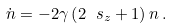Convert formula to latex. <formula><loc_0><loc_0><loc_500><loc_500>\dot { n } = - 2 \gamma \left ( 2 \ s _ { z } + 1 \right ) n \, .</formula> 